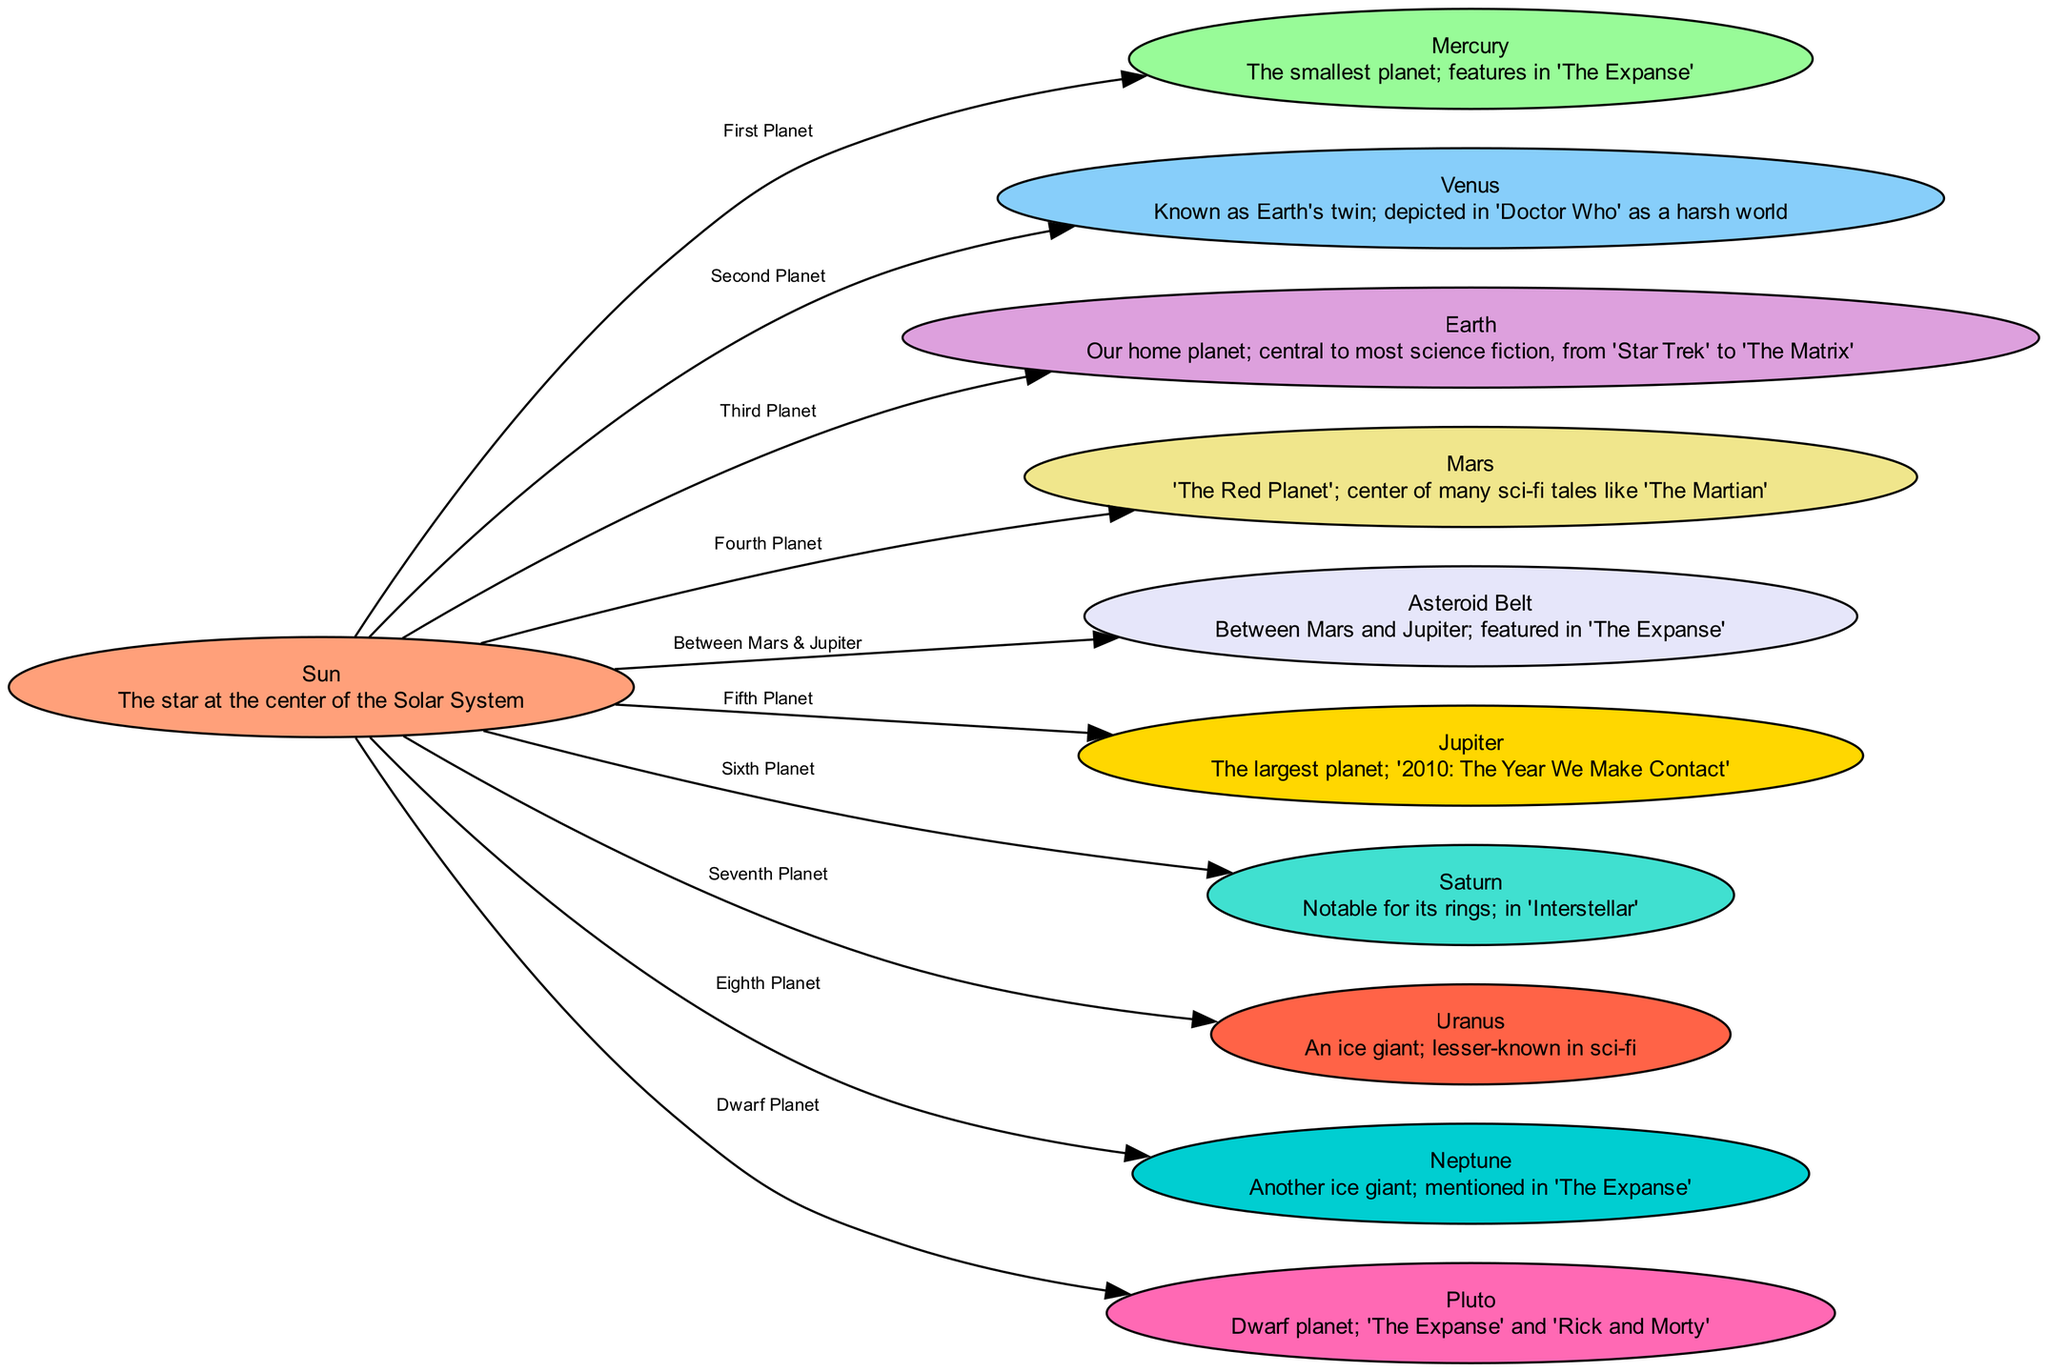What is the center of the Solar System? The diagram indicates that the Sun is the central node, representing the star at the center of our Solar System.
Answer: Sun How many planets are there in the diagram? By counting the nodes connected to the Sun, we find there are eight planets (including Pluto as a dwarf planet), resulting in a total of nine planetary bodies represented in the diagram.
Answer: Nine Which planet is depicted as "Earth's twin"? The node labeled Venus has the description indicating it is known as Earth's twin, highlighting its similarity in size and composition to Earth.
Answer: Venus What is the relationship between Mars and the Asteroid Belt? The diagram shows that the Asteroid Belt connects directly between Mars and Jupiter, indicating their spatial relationship in the Solar System, where the Asteroid Belt lies between these two planets.
Answer: Between Mars and Jupiter Which planet is featured in 'Interstellar'? The diagram identifies Saturn as being notable for its rings and states its feature in the movie 'Interstellar,' indicating its role in science fiction narratives.
Answer: Saturn List the two ice giants in the Solar System based on the diagram. The nodes for Uranus and Neptune are designated as ice giants, distinguishing them from other planets by their composition and location in the Solar System.
Answer: Uranus and Neptune What sci-fi narrative centers around "The Martian"? The reference within the Mars node indicates that it is called "The Red Planet" and is central to the sci-fi tale known as 'The Martian', showcasing how it features prominently in literature.
Answer: The Martian In which position does Jupiter rank among the planets? According to the edge labels, Jupiter is the fifth planet from the Sun, illustrating its order in the Solar System.
Answer: Fifth Planet What is the dwarf planet mentioned in the diagram? The diagram specifies Pluto as a dwarf planet, distinguishing it from the other eight major planets of the Solar System.
Answer: Pluto 